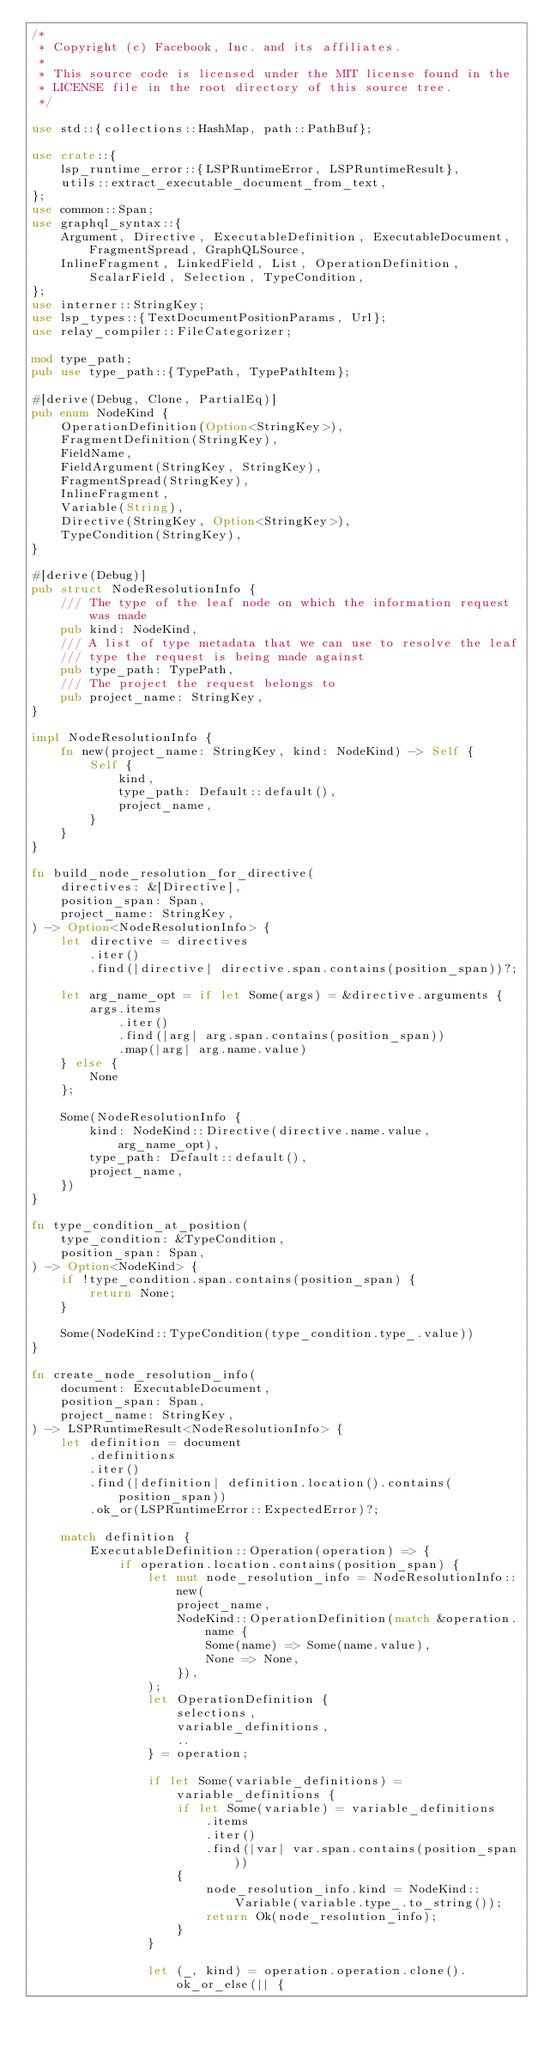Convert code to text. <code><loc_0><loc_0><loc_500><loc_500><_Rust_>/*
 * Copyright (c) Facebook, Inc. and its affiliates.
 *
 * This source code is licensed under the MIT license found in the
 * LICENSE file in the root directory of this source tree.
 */

use std::{collections::HashMap, path::PathBuf};

use crate::{
    lsp_runtime_error::{LSPRuntimeError, LSPRuntimeResult},
    utils::extract_executable_document_from_text,
};
use common::Span;
use graphql_syntax::{
    Argument, Directive, ExecutableDefinition, ExecutableDocument, FragmentSpread, GraphQLSource,
    InlineFragment, LinkedField, List, OperationDefinition, ScalarField, Selection, TypeCondition,
};
use interner::StringKey;
use lsp_types::{TextDocumentPositionParams, Url};
use relay_compiler::FileCategorizer;

mod type_path;
pub use type_path::{TypePath, TypePathItem};

#[derive(Debug, Clone, PartialEq)]
pub enum NodeKind {
    OperationDefinition(Option<StringKey>),
    FragmentDefinition(StringKey),
    FieldName,
    FieldArgument(StringKey, StringKey),
    FragmentSpread(StringKey),
    InlineFragment,
    Variable(String),
    Directive(StringKey, Option<StringKey>),
    TypeCondition(StringKey),
}

#[derive(Debug)]
pub struct NodeResolutionInfo {
    /// The type of the leaf node on which the information request was made
    pub kind: NodeKind,
    /// A list of type metadata that we can use to resolve the leaf
    /// type the request is being made against
    pub type_path: TypePath,
    /// The project the request belongs to
    pub project_name: StringKey,
}

impl NodeResolutionInfo {
    fn new(project_name: StringKey, kind: NodeKind) -> Self {
        Self {
            kind,
            type_path: Default::default(),
            project_name,
        }
    }
}

fn build_node_resolution_for_directive(
    directives: &[Directive],
    position_span: Span,
    project_name: StringKey,
) -> Option<NodeResolutionInfo> {
    let directive = directives
        .iter()
        .find(|directive| directive.span.contains(position_span))?;

    let arg_name_opt = if let Some(args) = &directive.arguments {
        args.items
            .iter()
            .find(|arg| arg.span.contains(position_span))
            .map(|arg| arg.name.value)
    } else {
        None
    };

    Some(NodeResolutionInfo {
        kind: NodeKind::Directive(directive.name.value, arg_name_opt),
        type_path: Default::default(),
        project_name,
    })
}

fn type_condition_at_position(
    type_condition: &TypeCondition,
    position_span: Span,
) -> Option<NodeKind> {
    if !type_condition.span.contains(position_span) {
        return None;
    }

    Some(NodeKind::TypeCondition(type_condition.type_.value))
}

fn create_node_resolution_info(
    document: ExecutableDocument,
    position_span: Span,
    project_name: StringKey,
) -> LSPRuntimeResult<NodeResolutionInfo> {
    let definition = document
        .definitions
        .iter()
        .find(|definition| definition.location().contains(position_span))
        .ok_or(LSPRuntimeError::ExpectedError)?;

    match definition {
        ExecutableDefinition::Operation(operation) => {
            if operation.location.contains(position_span) {
                let mut node_resolution_info = NodeResolutionInfo::new(
                    project_name,
                    NodeKind::OperationDefinition(match &operation.name {
                        Some(name) => Some(name.value),
                        None => None,
                    }),
                );
                let OperationDefinition {
                    selections,
                    variable_definitions,
                    ..
                } = operation;

                if let Some(variable_definitions) = variable_definitions {
                    if let Some(variable) = variable_definitions
                        .items
                        .iter()
                        .find(|var| var.span.contains(position_span))
                    {
                        node_resolution_info.kind = NodeKind::Variable(variable.type_.to_string());
                        return Ok(node_resolution_info);
                    }
                }

                let (_, kind) = operation.operation.clone().ok_or_else(|| {</code> 